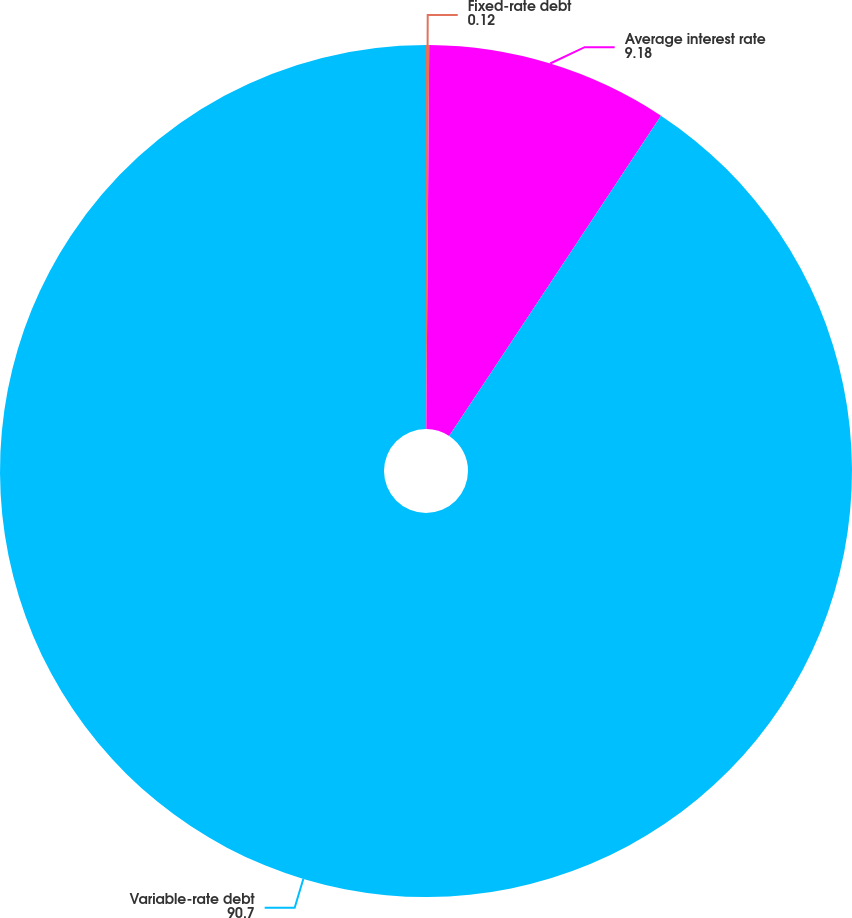<chart> <loc_0><loc_0><loc_500><loc_500><pie_chart><fcel>Fixed-rate debt<fcel>Average interest rate<fcel>Variable-rate debt<nl><fcel>0.12%<fcel>9.18%<fcel>90.7%<nl></chart> 